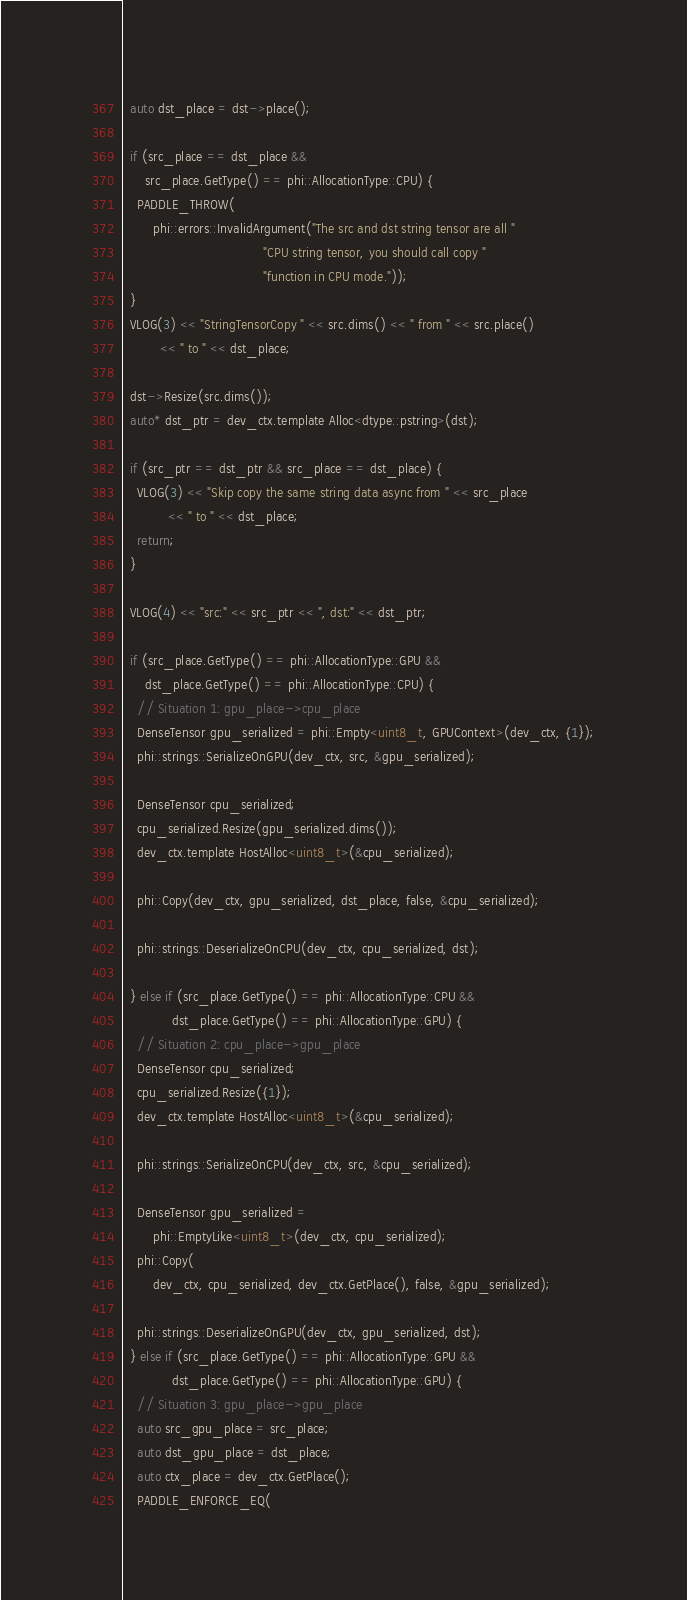<code> <loc_0><loc_0><loc_500><loc_500><_Cuda_>  auto dst_place = dst->place();

  if (src_place == dst_place &&
      src_place.GetType() == phi::AllocationType::CPU) {
    PADDLE_THROW(
        phi::errors::InvalidArgument("The src and dst string tensor are all "
                                     "CPU string tensor, you should call copy "
                                     "function in CPU mode."));
  }
  VLOG(3) << "StringTensorCopy " << src.dims() << " from " << src.place()
          << " to " << dst_place;

  dst->Resize(src.dims());
  auto* dst_ptr = dev_ctx.template Alloc<dtype::pstring>(dst);

  if (src_ptr == dst_ptr && src_place == dst_place) {
    VLOG(3) << "Skip copy the same string data async from " << src_place
            << " to " << dst_place;
    return;
  }

  VLOG(4) << "src:" << src_ptr << ", dst:" << dst_ptr;

  if (src_place.GetType() == phi::AllocationType::GPU &&
      dst_place.GetType() == phi::AllocationType::CPU) {
    // Situation 1: gpu_place->cpu_place
    DenseTensor gpu_serialized = phi::Empty<uint8_t, GPUContext>(dev_ctx, {1});
    phi::strings::SerializeOnGPU(dev_ctx, src, &gpu_serialized);

    DenseTensor cpu_serialized;
    cpu_serialized.Resize(gpu_serialized.dims());
    dev_ctx.template HostAlloc<uint8_t>(&cpu_serialized);

    phi::Copy(dev_ctx, gpu_serialized, dst_place, false, &cpu_serialized);

    phi::strings::DeserializeOnCPU(dev_ctx, cpu_serialized, dst);

  } else if (src_place.GetType() == phi::AllocationType::CPU &&
             dst_place.GetType() == phi::AllocationType::GPU) {
    // Situation 2: cpu_place->gpu_place
    DenseTensor cpu_serialized;
    cpu_serialized.Resize({1});
    dev_ctx.template HostAlloc<uint8_t>(&cpu_serialized);

    phi::strings::SerializeOnCPU(dev_ctx, src, &cpu_serialized);

    DenseTensor gpu_serialized =
        phi::EmptyLike<uint8_t>(dev_ctx, cpu_serialized);
    phi::Copy(
        dev_ctx, cpu_serialized, dev_ctx.GetPlace(), false, &gpu_serialized);

    phi::strings::DeserializeOnGPU(dev_ctx, gpu_serialized, dst);
  } else if (src_place.GetType() == phi::AllocationType::GPU &&
             dst_place.GetType() == phi::AllocationType::GPU) {
    // Situation 3: gpu_place->gpu_place
    auto src_gpu_place = src_place;
    auto dst_gpu_place = dst_place;
    auto ctx_place = dev_ctx.GetPlace();
    PADDLE_ENFORCE_EQ(</code> 